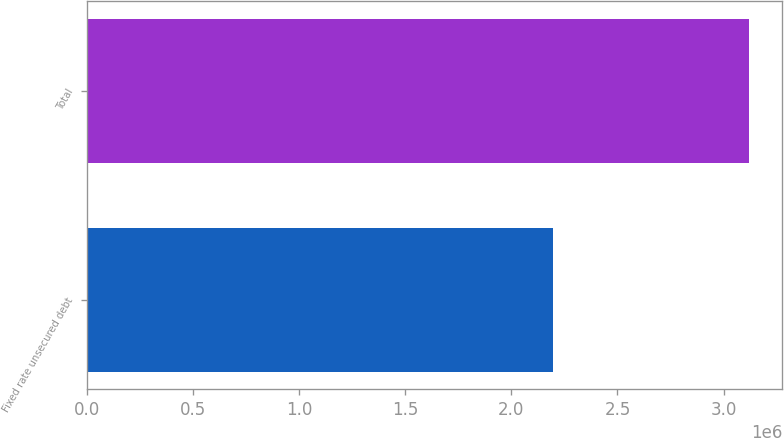Convert chart to OTSL. <chart><loc_0><loc_0><loc_500><loc_500><bar_chart><fcel>Fixed rate unsecured debt<fcel>Total<nl><fcel>2.19669e+06<fcel>3.12011e+06<nl></chart> 